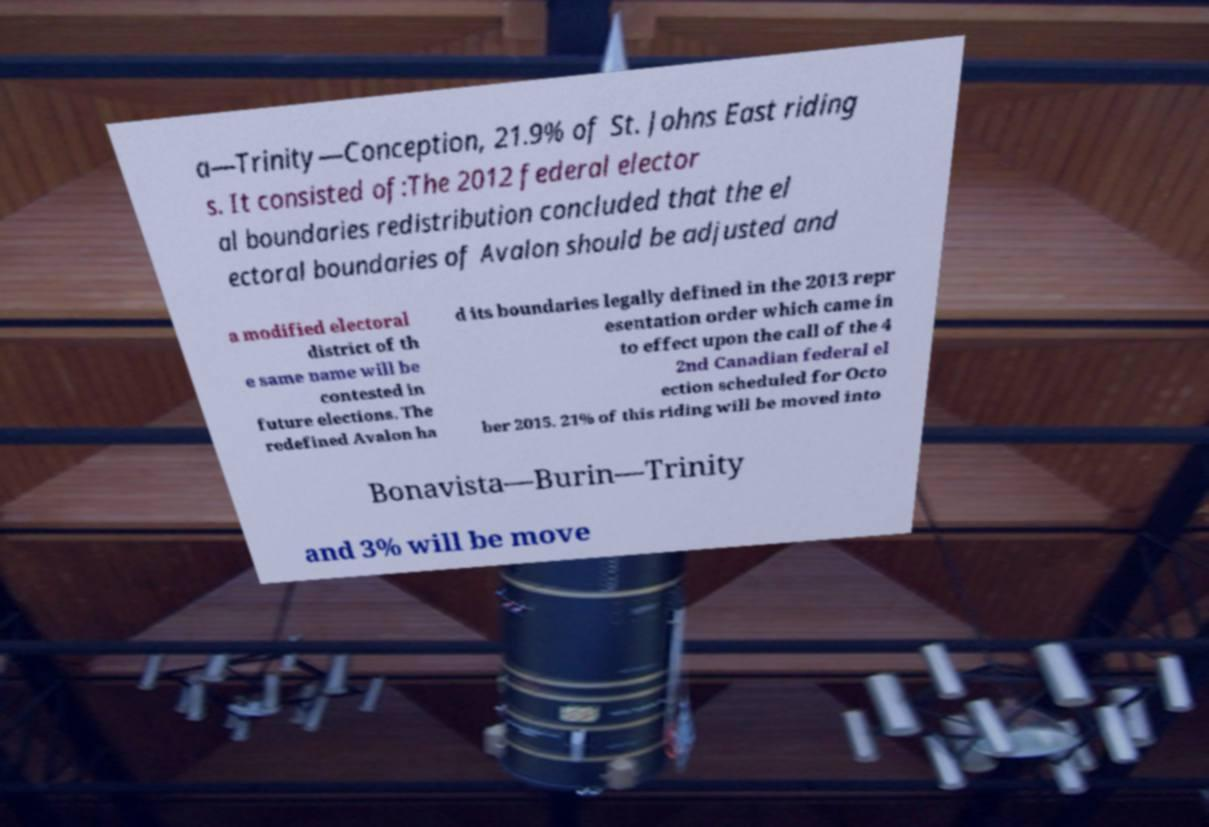Please identify and transcribe the text found in this image. a—Trinity—Conception, 21.9% of St. Johns East riding s. It consisted of:The 2012 federal elector al boundaries redistribution concluded that the el ectoral boundaries of Avalon should be adjusted and a modified electoral district of th e same name will be contested in future elections. The redefined Avalon ha d its boundaries legally defined in the 2013 repr esentation order which came in to effect upon the call of the 4 2nd Canadian federal el ection scheduled for Octo ber 2015. 21% of this riding will be moved into Bonavista—Burin—Trinity and 3% will be move 